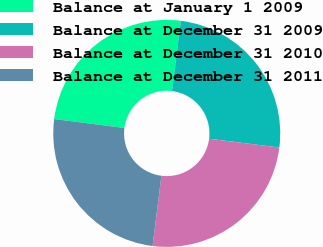Convert chart. <chart><loc_0><loc_0><loc_500><loc_500><pie_chart><fcel>Balance at January 1 2009<fcel>Balance at December 31 2009<fcel>Balance at December 31 2010<fcel>Balance at December 31 2011<nl><fcel>24.96%<fcel>25.0%<fcel>25.01%<fcel>25.03%<nl></chart> 